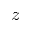<formula> <loc_0><loc_0><loc_500><loc_500>z</formula> 